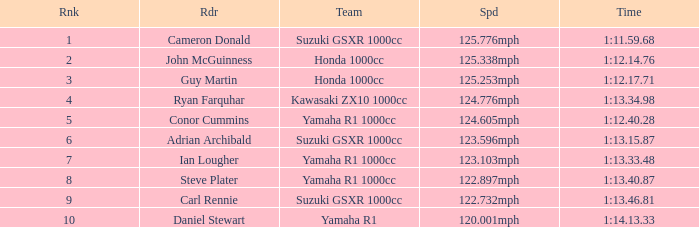What is the rank for the team with a Time of 1:12.40.28? 5.0. 